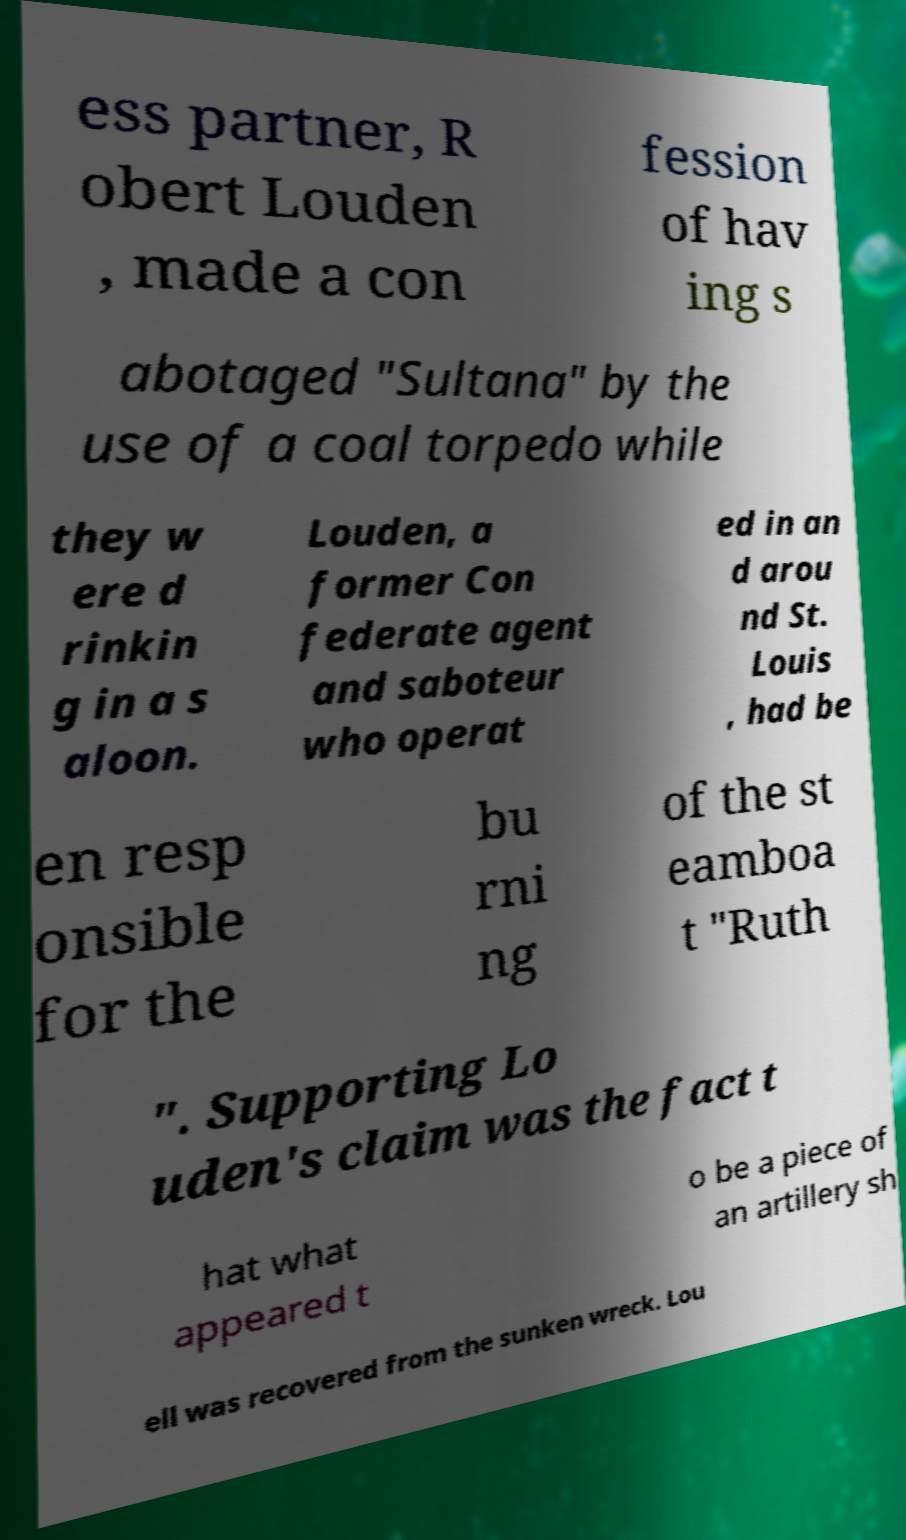Can you accurately transcribe the text from the provided image for me? ess partner, R obert Louden , made a con fession of hav ing s abotaged "Sultana" by the use of a coal torpedo while they w ere d rinkin g in a s aloon. Louden, a former Con federate agent and saboteur who operat ed in an d arou nd St. Louis , had be en resp onsible for the bu rni ng of the st eamboa t "Ruth ". Supporting Lo uden's claim was the fact t hat what appeared t o be a piece of an artillery sh ell was recovered from the sunken wreck. Lou 